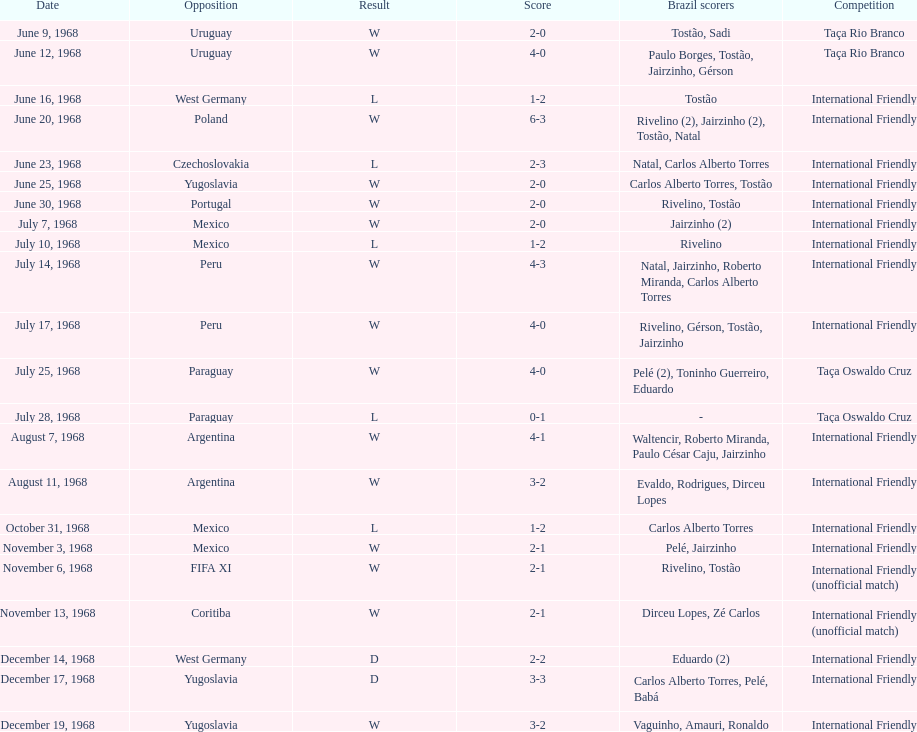Can you provide the amount of losses? 5. 